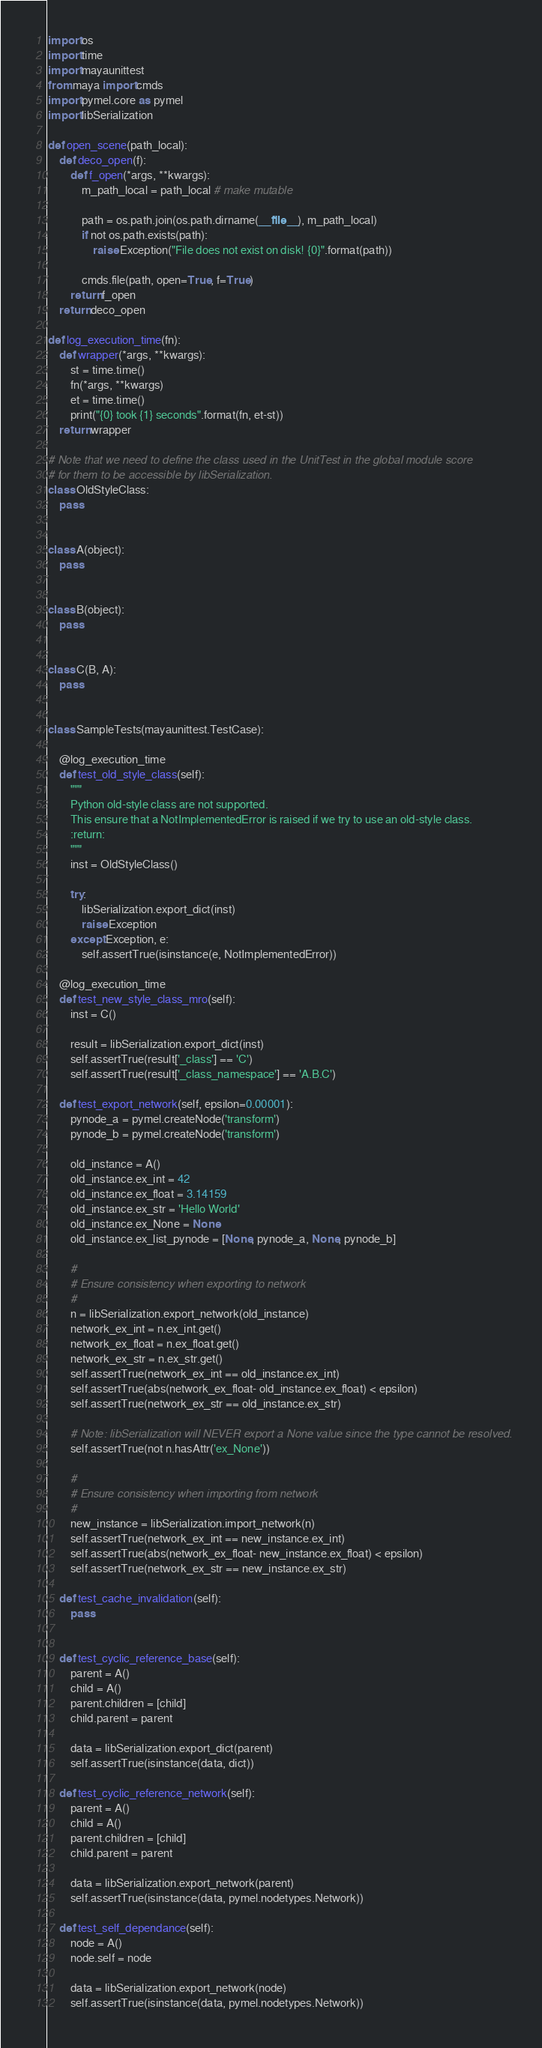Convert code to text. <code><loc_0><loc_0><loc_500><loc_500><_Python_>import os
import time
import mayaunittest
from maya import cmds
import pymel.core as pymel
import libSerialization

def open_scene(path_local):
    def deco_open(f):
        def f_open(*args, **kwargs):
            m_path_local = path_local # make mutable

            path = os.path.join(os.path.dirname(__file__), m_path_local)
            if not os.path.exists(path):
                raise Exception("File does not exist on disk! {0}".format(path))

            cmds.file(path, open=True, f=True)
        return f_open
    return deco_open

def log_execution_time(fn):
    def wrapper(*args, **kwargs):
        st = time.time()
        fn(*args, **kwargs)
        et = time.time()
        print("{0} took {1} seconds".format(fn, et-st))
    return wrapper

# Note that we need to define the class used in the UnitTest in the global module score
# for them to be accessible by libSerialization.
class OldStyleClass:
    pass


class A(object):
    pass


class B(object):
    pass


class C(B, A):
    pass


class SampleTests(mayaunittest.TestCase):

    @log_execution_time
    def test_old_style_class(self):
        """
        Python old-style class are not supported.
        This ensure that a NotImplementedError is raised if we try to use an old-style class.
        :return:
        """
        inst = OldStyleClass()

        try:
            libSerialization.export_dict(inst)
            raise Exception
        except Exception, e:
            self.assertTrue(isinstance(e, NotImplementedError))

    @log_execution_time
    def test_new_style_class_mro(self):
        inst = C()

        result = libSerialization.export_dict(inst)
        self.assertTrue(result['_class'] == 'C')
        self.assertTrue(result['_class_namespace'] == 'A.B.C')

    def test_export_network(self, epsilon=0.00001):
        pynode_a = pymel.createNode('transform')
        pynode_b = pymel.createNode('transform')

        old_instance = A()
        old_instance.ex_int = 42
        old_instance.ex_float = 3.14159
        old_instance.ex_str = 'Hello World'
        old_instance.ex_None = None
        old_instance.ex_list_pynode = [None, pynode_a, None, pynode_b]

        #
        # Ensure consistency when exporting to network
        #
        n = libSerialization.export_network(old_instance)
        network_ex_int = n.ex_int.get()
        network_ex_float = n.ex_float.get()
        network_ex_str = n.ex_str.get()
        self.assertTrue(network_ex_int == old_instance.ex_int)
        self.assertTrue(abs(network_ex_float- old_instance.ex_float) < epsilon)
        self.assertTrue(network_ex_str == old_instance.ex_str)

        # Note: libSerialization will NEVER export a None value since the type cannot be resolved.
        self.assertTrue(not n.hasAttr('ex_None'))

        #
        # Ensure consistency when importing from network
        #
        new_instance = libSerialization.import_network(n)
        self.assertTrue(network_ex_int == new_instance.ex_int)
        self.assertTrue(abs(network_ex_float- new_instance.ex_float) < epsilon)
        self.assertTrue(network_ex_str == new_instance.ex_str)

    def test_cache_invalidation(self):
        pass


    def test_cyclic_reference_base(self):
        parent = A()
        child = A()
        parent.children = [child]
        child.parent = parent

        data = libSerialization.export_dict(parent)
        self.assertTrue(isinstance(data, dict))

    def test_cyclic_reference_network(self):
        parent = A()
        child = A()
        parent.children = [child]
        child.parent = parent

        data = libSerialization.export_network(parent)
        self.assertTrue(isinstance(data, pymel.nodetypes.Network))

    def test_self_dependance(self):
        node = A()
        node.self = node

        data = libSerialization.export_network(node)
        self.assertTrue(isinstance(data, pymel.nodetypes.Network))


</code> 